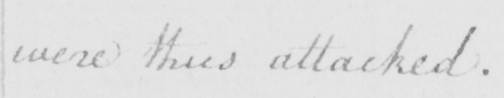Please provide the text content of this handwritten line. were thus attacked . 